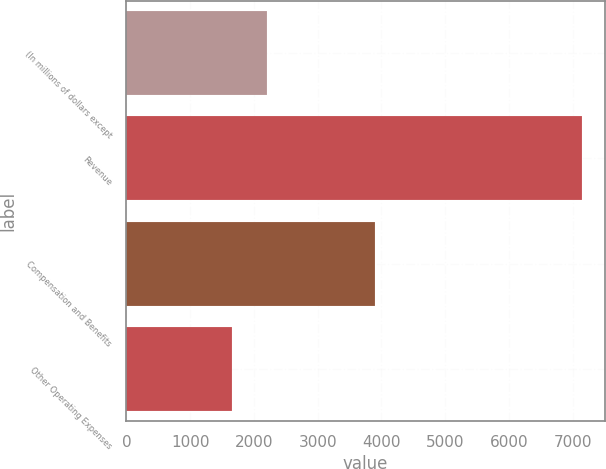<chart> <loc_0><loc_0><loc_500><loc_500><bar_chart><fcel>(In millions of dollars except<fcel>Revenue<fcel>Compensation and Benefits<fcel>Other Operating Expenses<nl><fcel>2206.5<fcel>7143<fcel>3904<fcel>1658<nl></chart> 